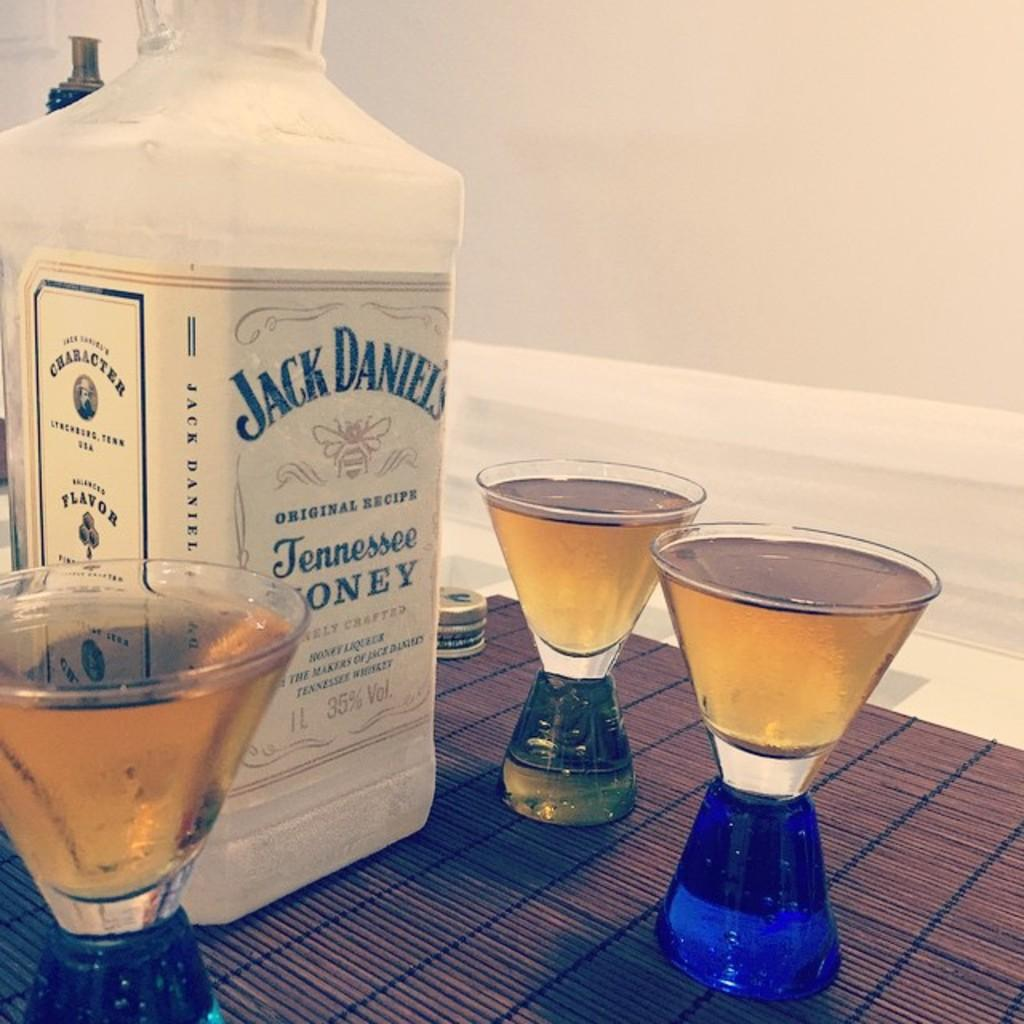Provide a one-sentence caption for the provided image. A bottle of Jack Daniels is surrounded by full glasses. 